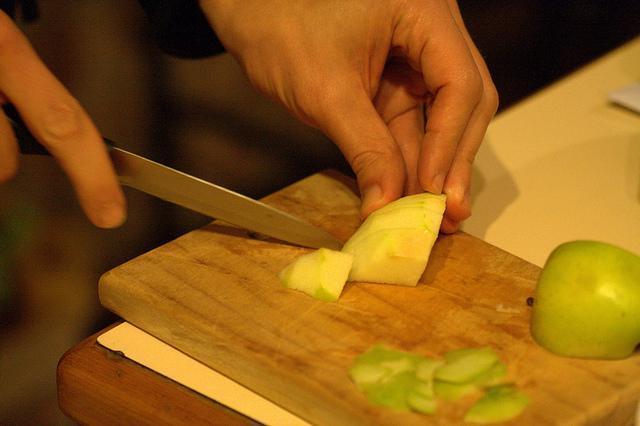How many apples are visible?
Give a very brief answer. 4. How many giraffes are facing the camera?
Give a very brief answer. 0. 